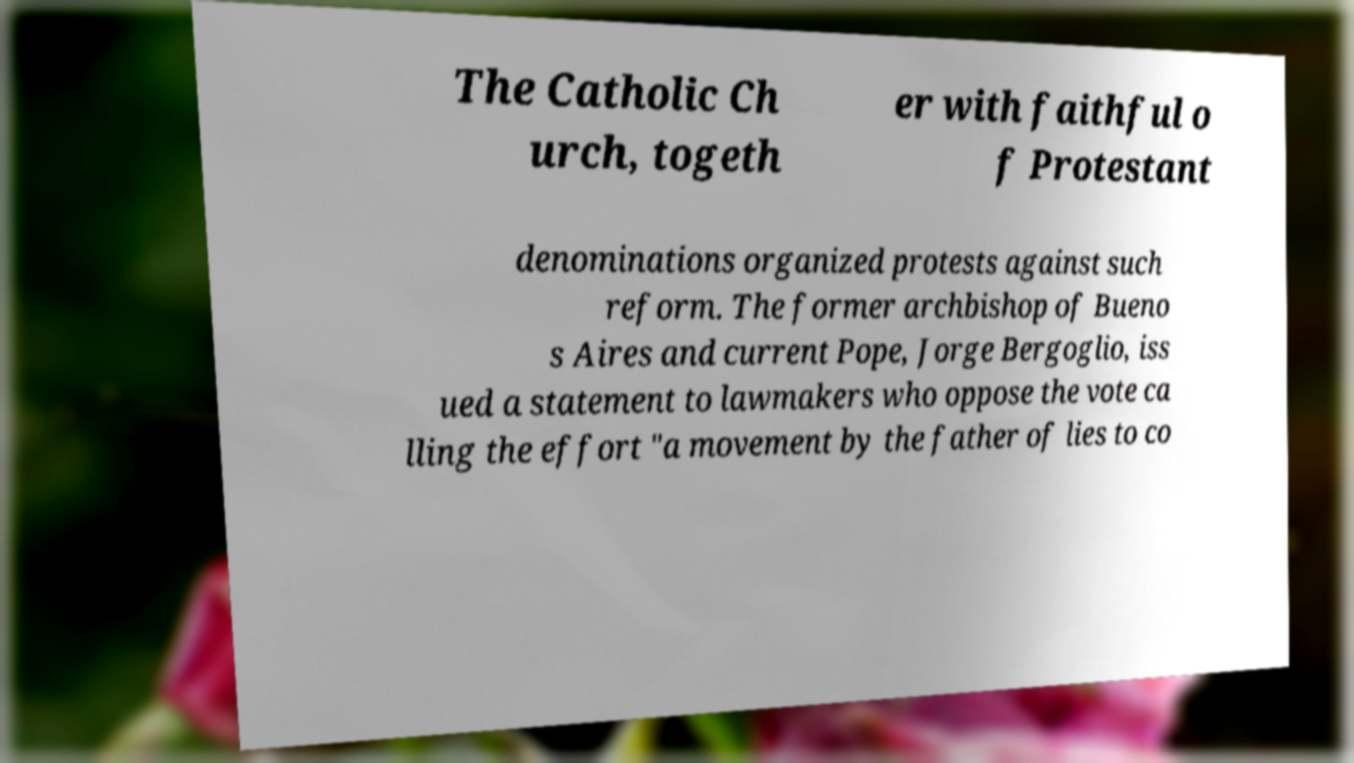Please identify and transcribe the text found in this image. The Catholic Ch urch, togeth er with faithful o f Protestant denominations organized protests against such reform. The former archbishop of Bueno s Aires and current Pope, Jorge Bergoglio, iss ued a statement to lawmakers who oppose the vote ca lling the effort "a movement by the father of lies to co 